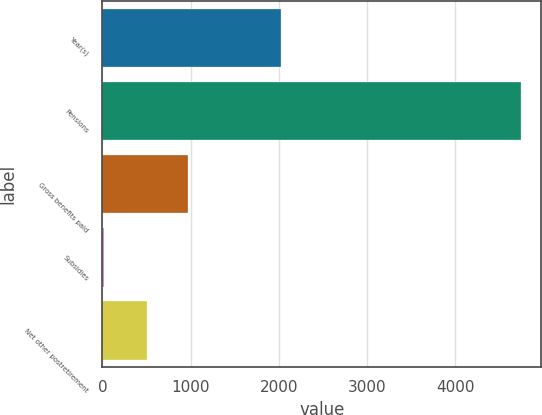Convert chart. <chart><loc_0><loc_0><loc_500><loc_500><bar_chart><fcel>Year(s)<fcel>Pensions<fcel>Gross benefits paid<fcel>Subsidies<fcel>Net other postretirement<nl><fcel>2020<fcel>4740<fcel>972.3<fcel>17<fcel>500<nl></chart> 